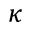<formula> <loc_0><loc_0><loc_500><loc_500>\kappa</formula> 